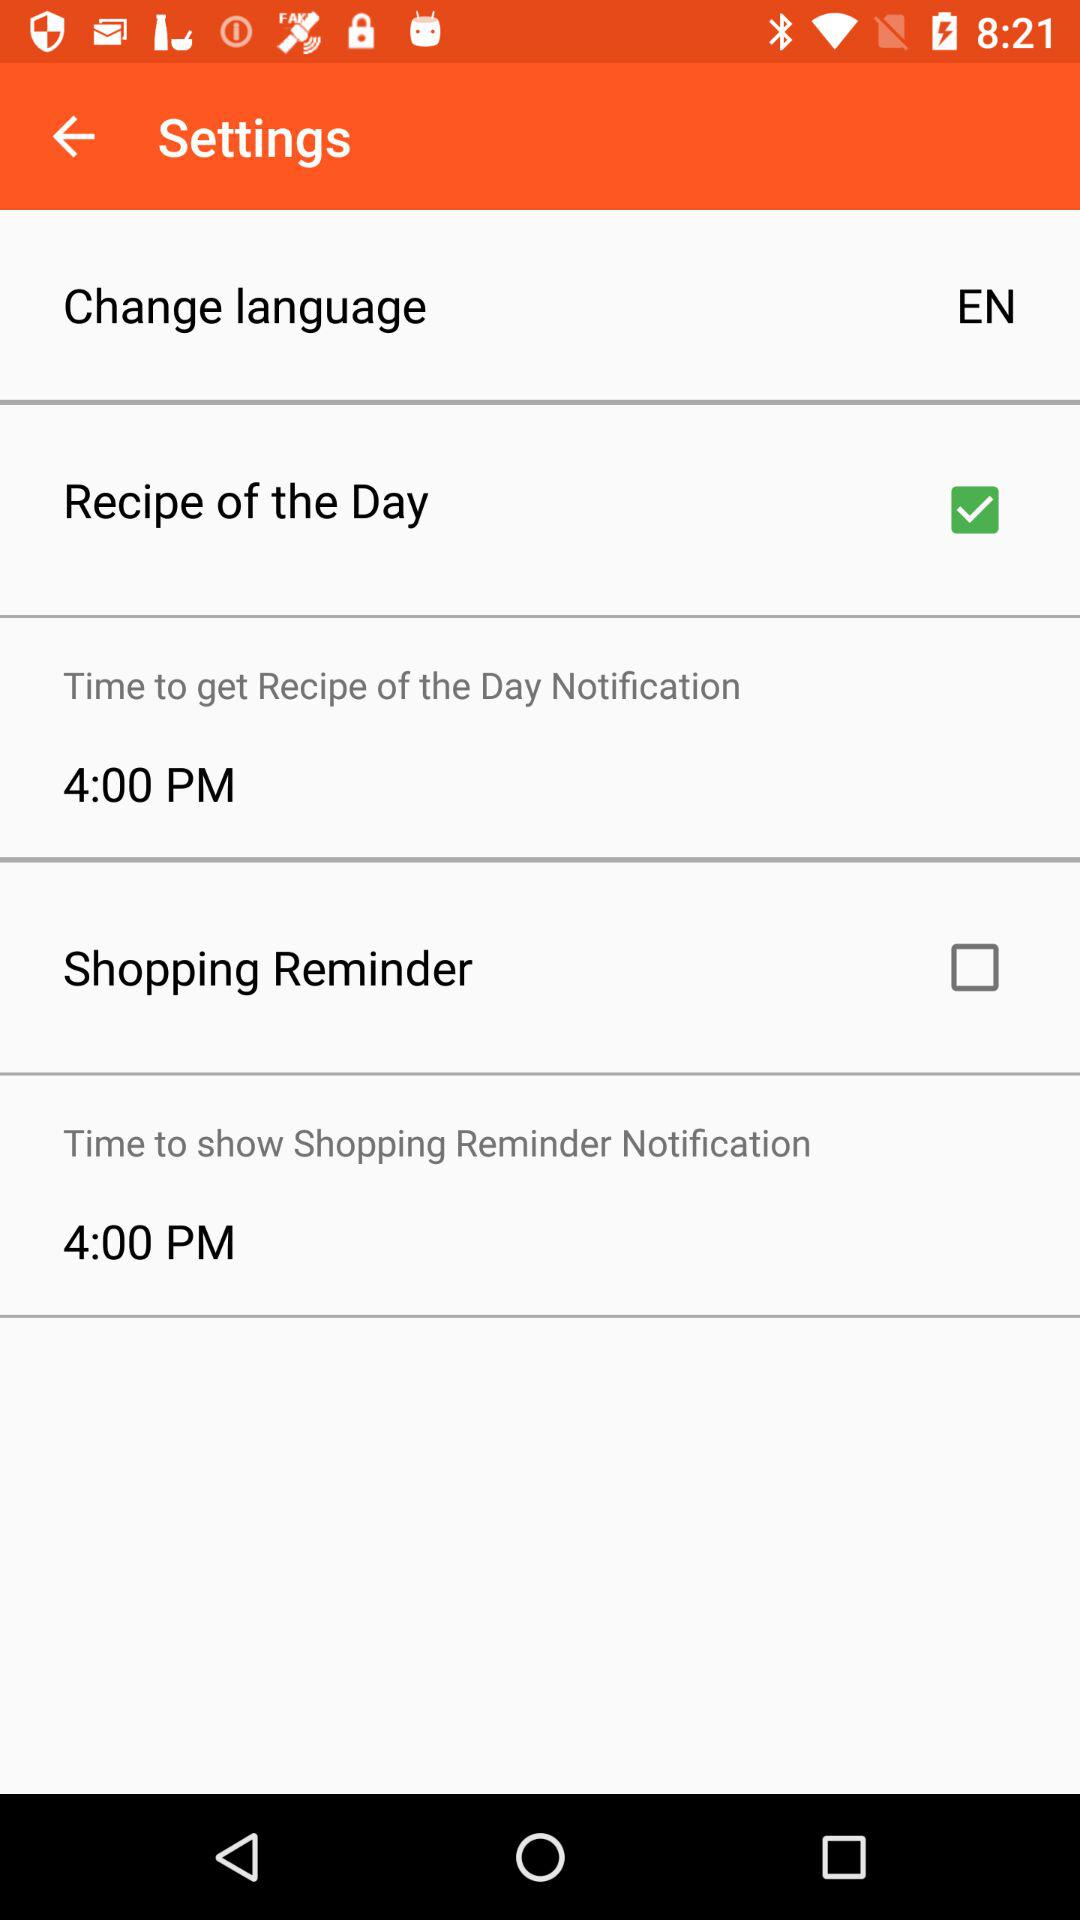What's the selected language for the application? The selected language is English. 